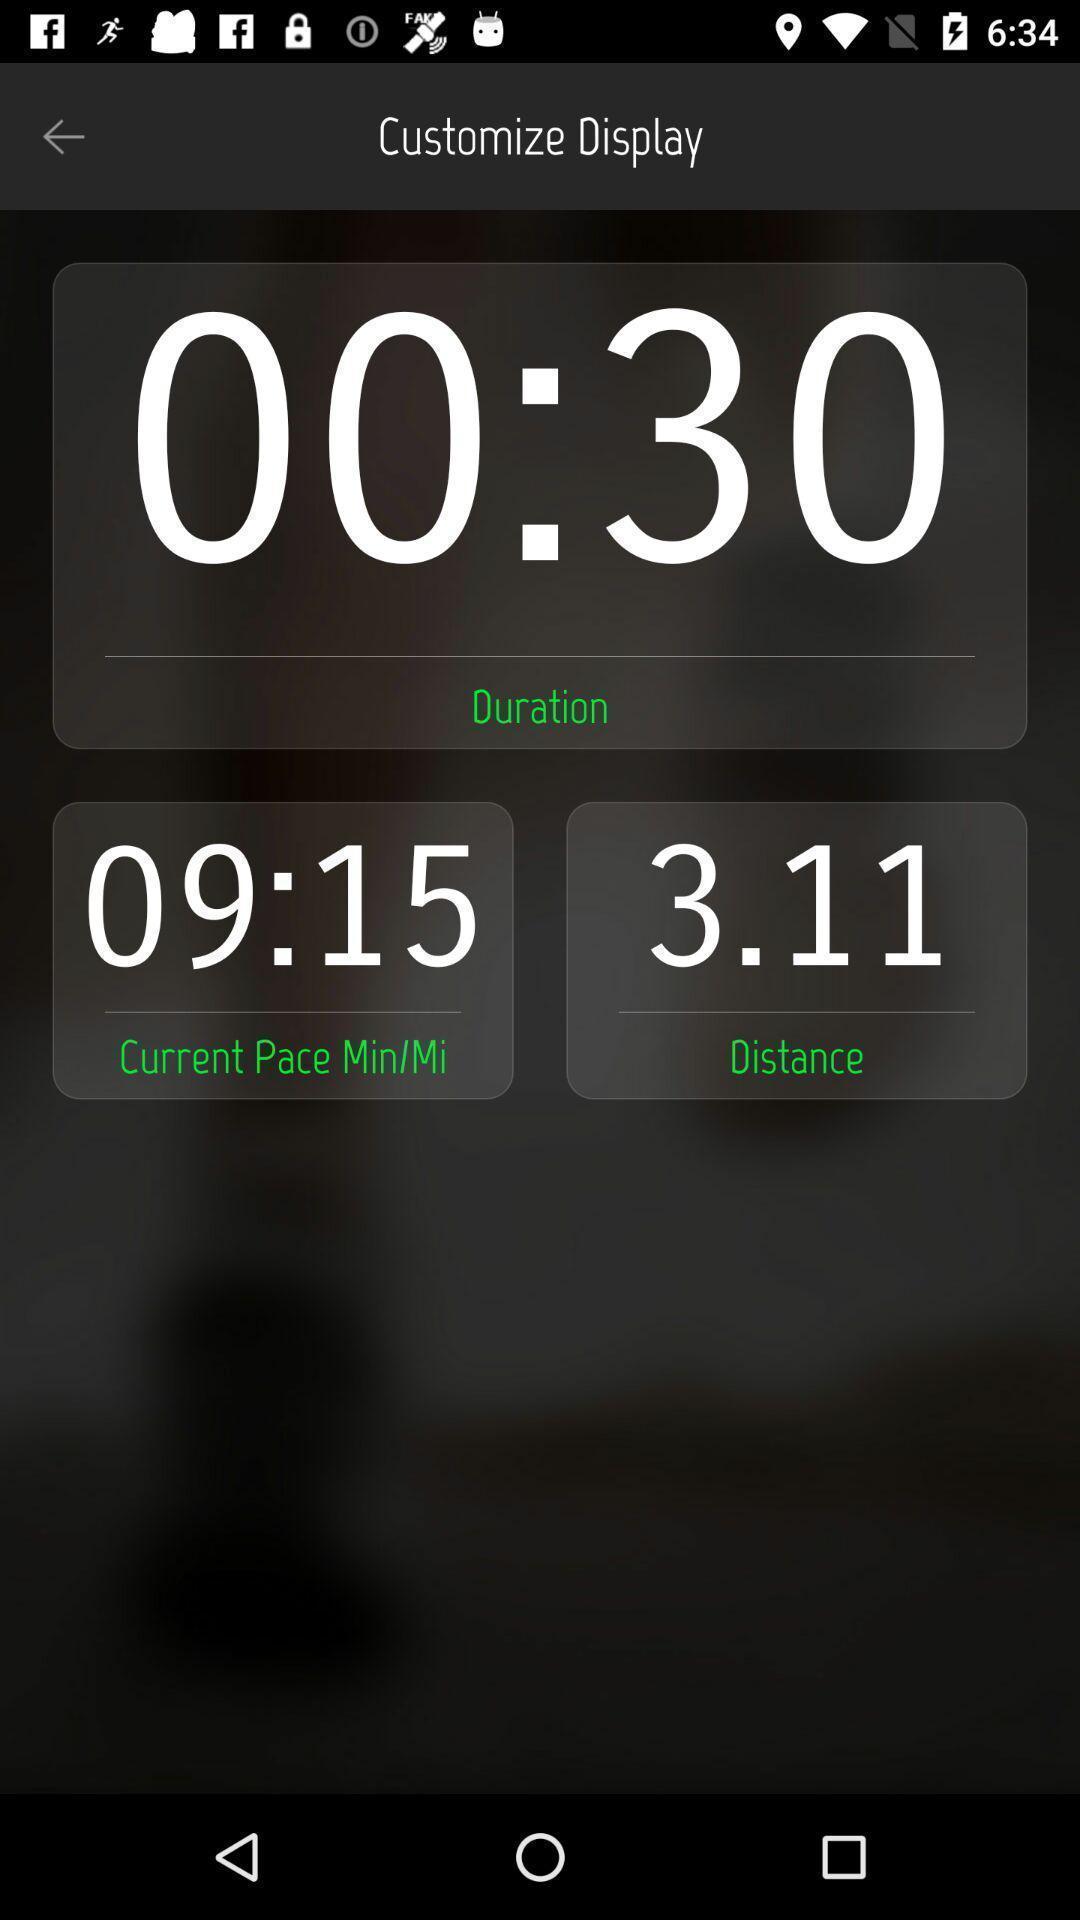Summarize the main components in this picture. Page for tracking time and distance of a workout app. 